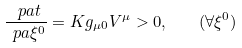<formula> <loc_0><loc_0><loc_500><loc_500>\frac { \ p a t } { \ p a { \xi ^ { 0 } } } = K g _ { \mu 0 } V ^ { \mu } > 0 , \quad ( \forall \xi ^ { 0 } )</formula> 